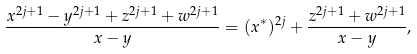<formula> <loc_0><loc_0><loc_500><loc_500>\frac { x ^ { 2 j + 1 } - y ^ { 2 j + 1 } + z ^ { 2 j + 1 } + w ^ { 2 j + 1 } } { x - y } = ( x ^ { \ast } ) ^ { 2 j } + \frac { z ^ { 2 j + 1 } + w ^ { 2 j + 1 } } { x - y } ,</formula> 